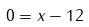<formula> <loc_0><loc_0><loc_500><loc_500>0 = x - 1 2</formula> 